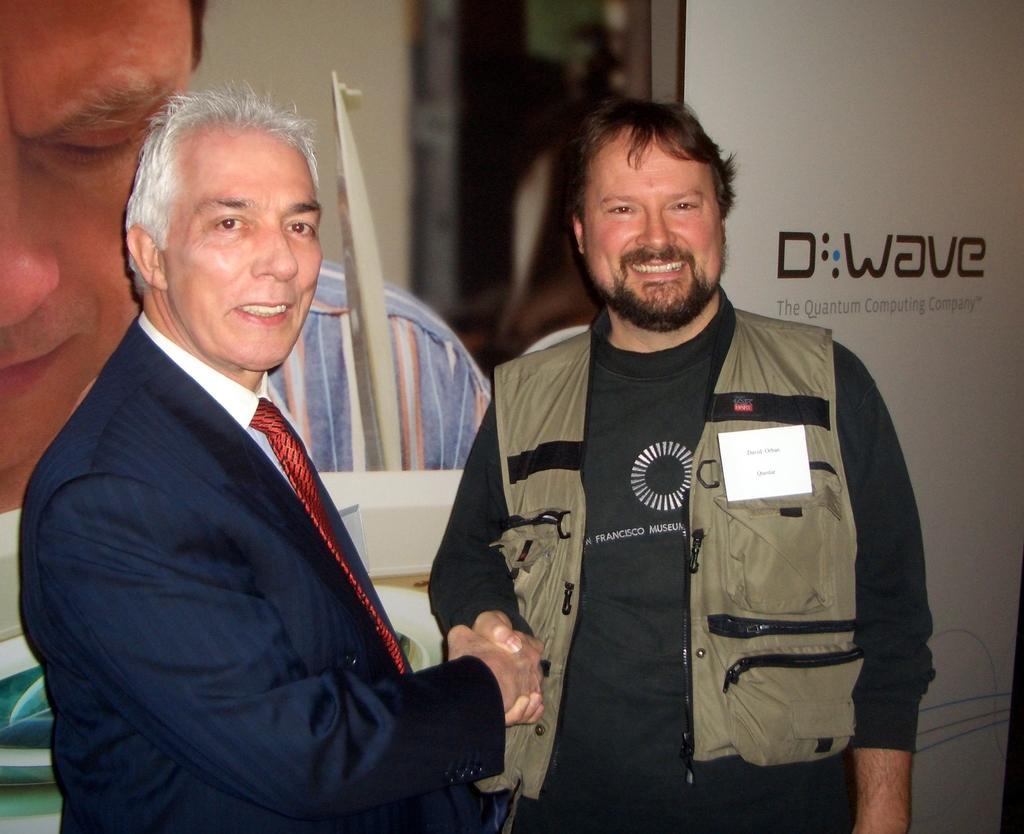Describe this image in one or two sentences. In this picture I can see two persons shaking their hands, behind I can see a banner. 